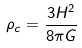Convert formula to latex. <formula><loc_0><loc_0><loc_500><loc_500>\rho _ { c } = \frac { 3 H ^ { 2 } } { 8 \pi G }</formula> 